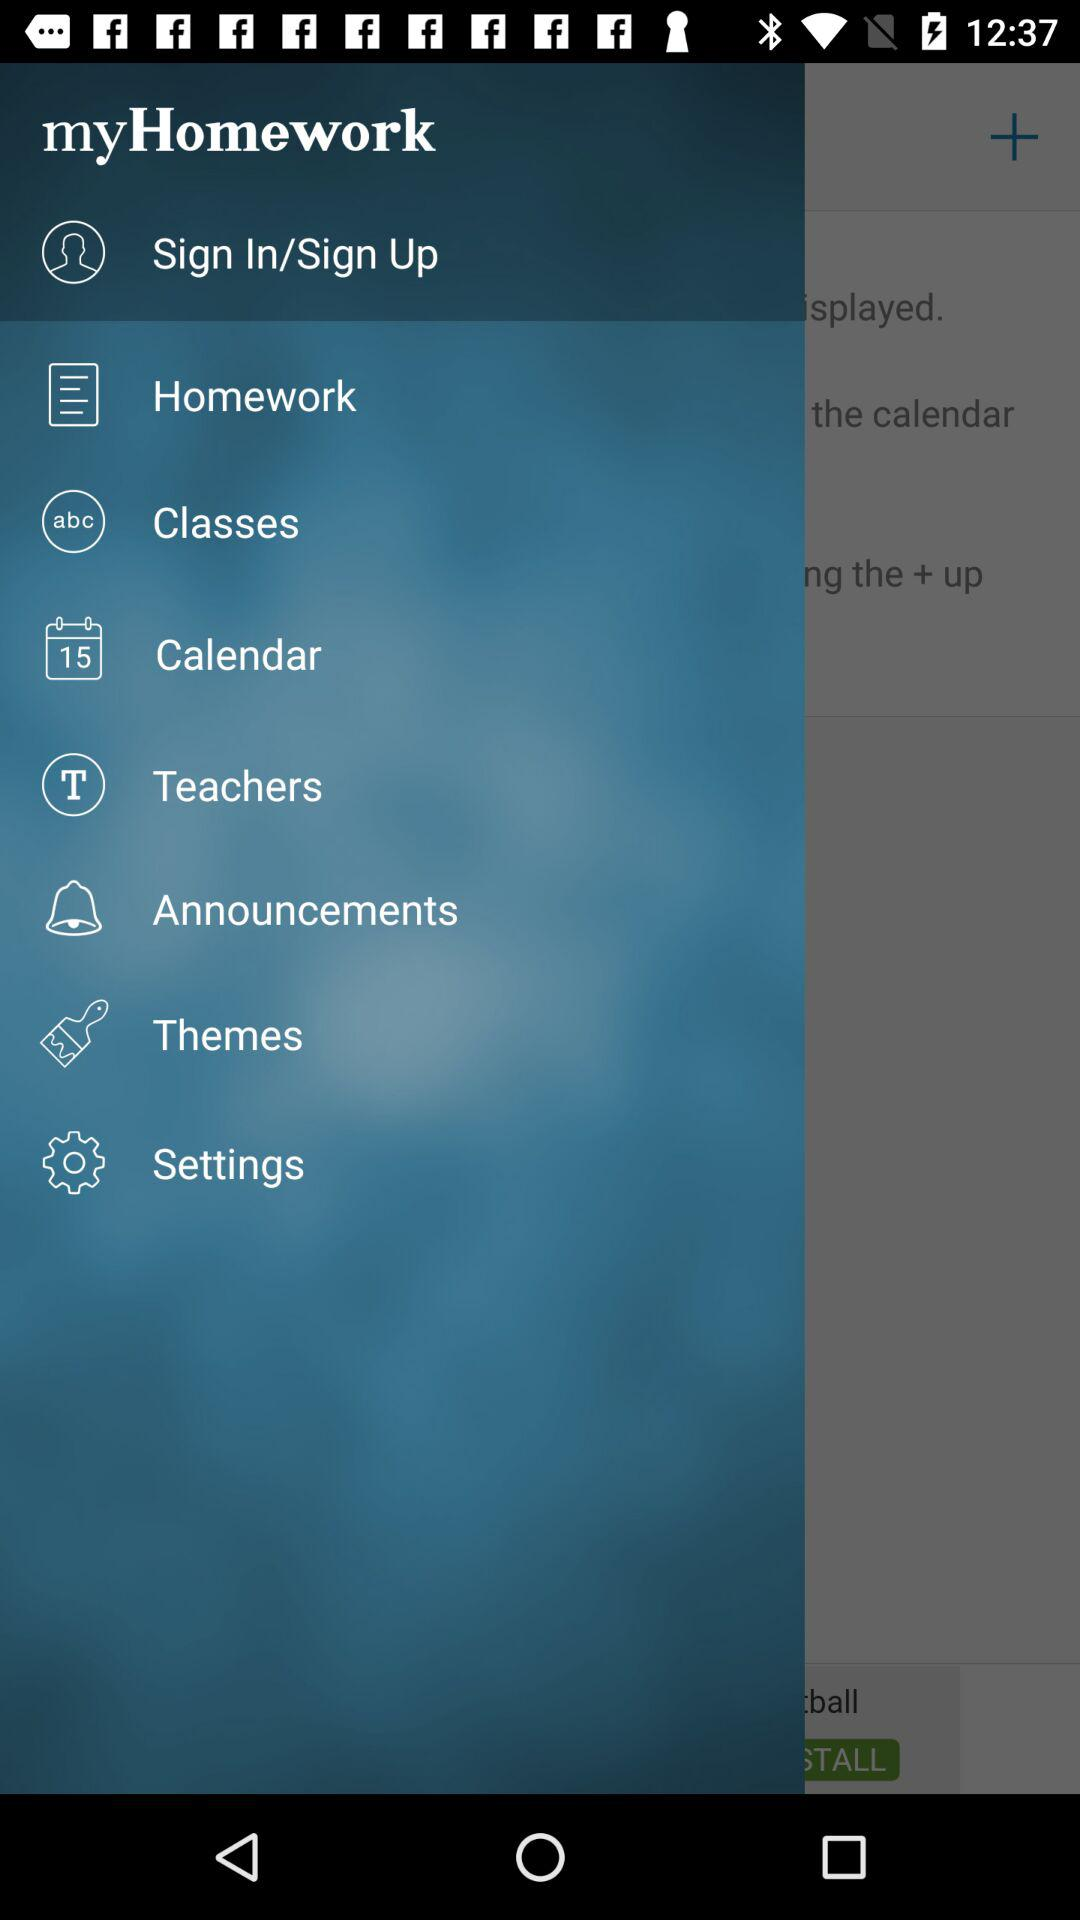What is the mentioned date on the calendar?
When the provided information is insufficient, respond with <no answer>. <no answer> 